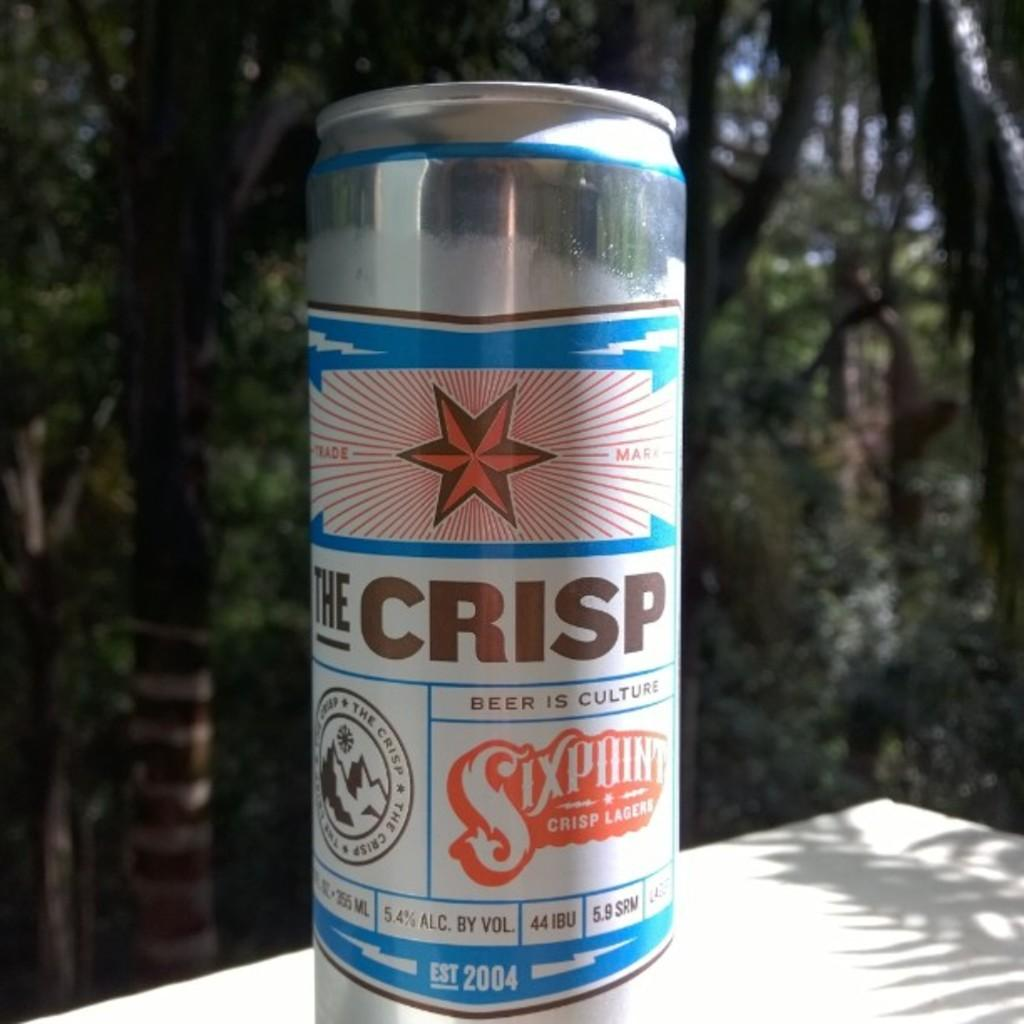<image>
Provide a brief description of the given image. A can of The Crisp sits on a table in the sunshine. 